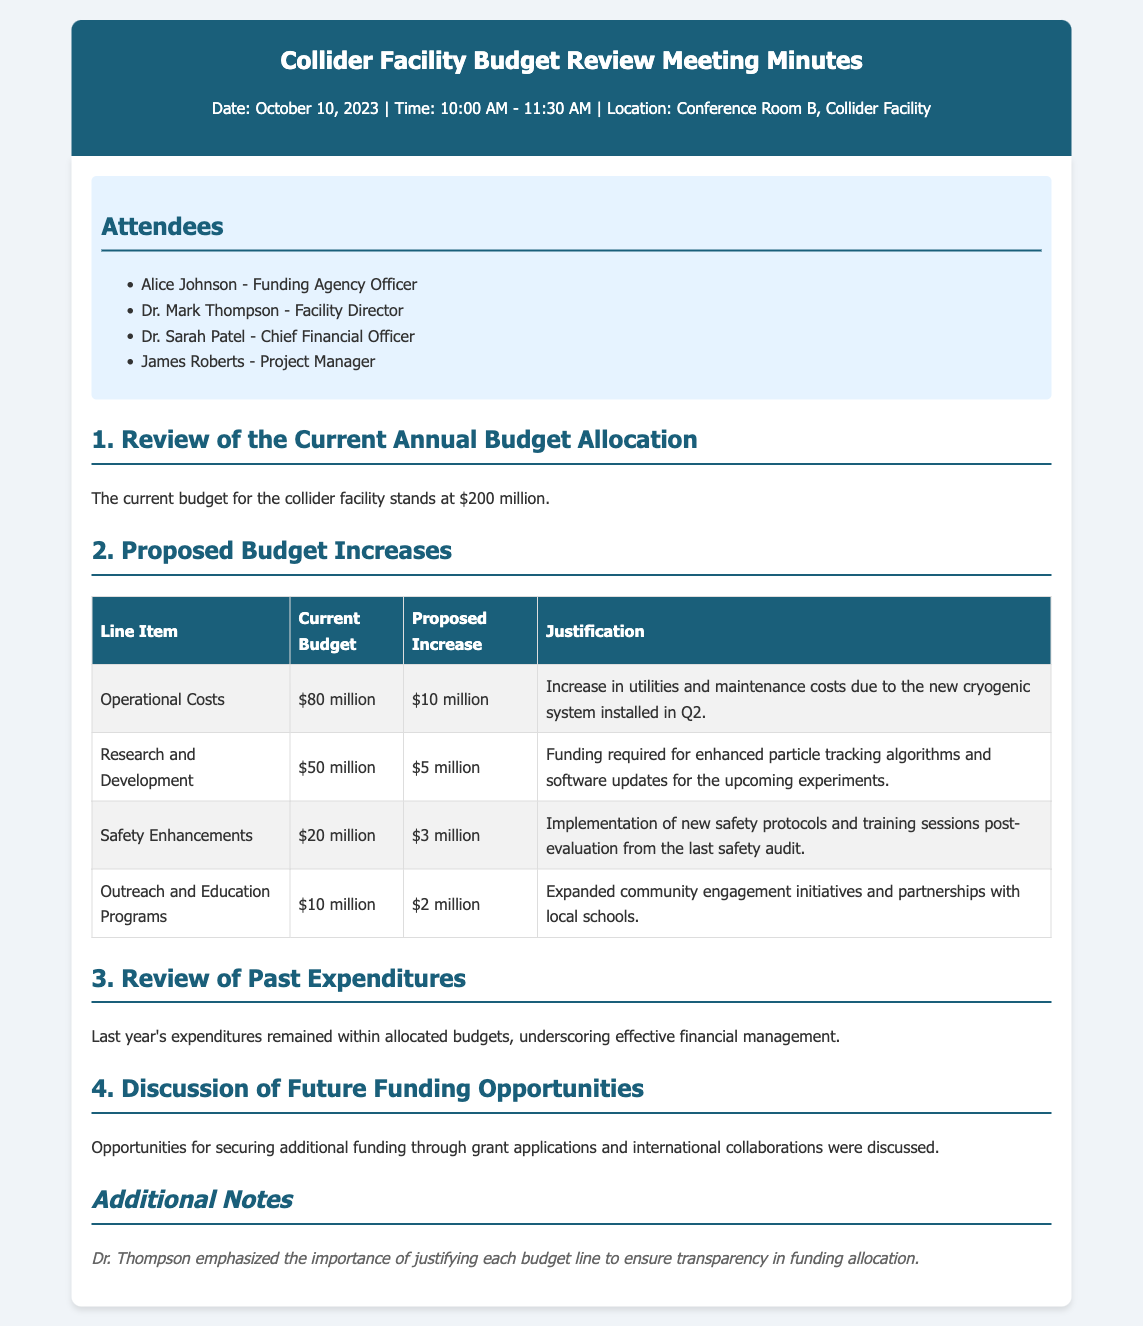What is the current budget for the collider facility? The current budget is explicitly stated in the document, which is $200 million.
Answer: $200 million How much is the proposed increase for operational costs? The document provides the proposed increase for operational costs, which is $10 million.
Answer: $10 million What is the justification for the increase in research and development? The justification provided in the document states that funding is required for enhanced particle tracking algorithms and software updates.
Answer: Enhanced particle tracking algorithms and software updates How many attendees were present at the meeting? The document lists the attendees, totaling four individuals, including the Funding Agency Officer.
Answer: 4 What line item has the smallest proposed increase? By comparing the proposed increases listed, safety enhancements show the smallest increase, which is $3 million.
Answer: Safety Enhancements What was emphasized by Dr. Thompson regarding budget allocations? The document notes that Dr. Thompson emphasized the importance of justifying each budget line for transparency in allocation.
Answer: Importance of justifying each budget line What was the total proposed increase for all line items combined? The total of all proposed increases can be calculated from the table, which totals $20 million ($10 million + $5 million + $3 million + $2 million).
Answer: $20 million What date was the meeting held? The document specifies the meeting date as October 10, 2023.
Answer: October 10, 2023 What percentage of the budget is allocated to safety enhancements? The safety enhancements are allocated $20 million from the total budget of $200 million, which accounts for 10%.
Answer: 10% 